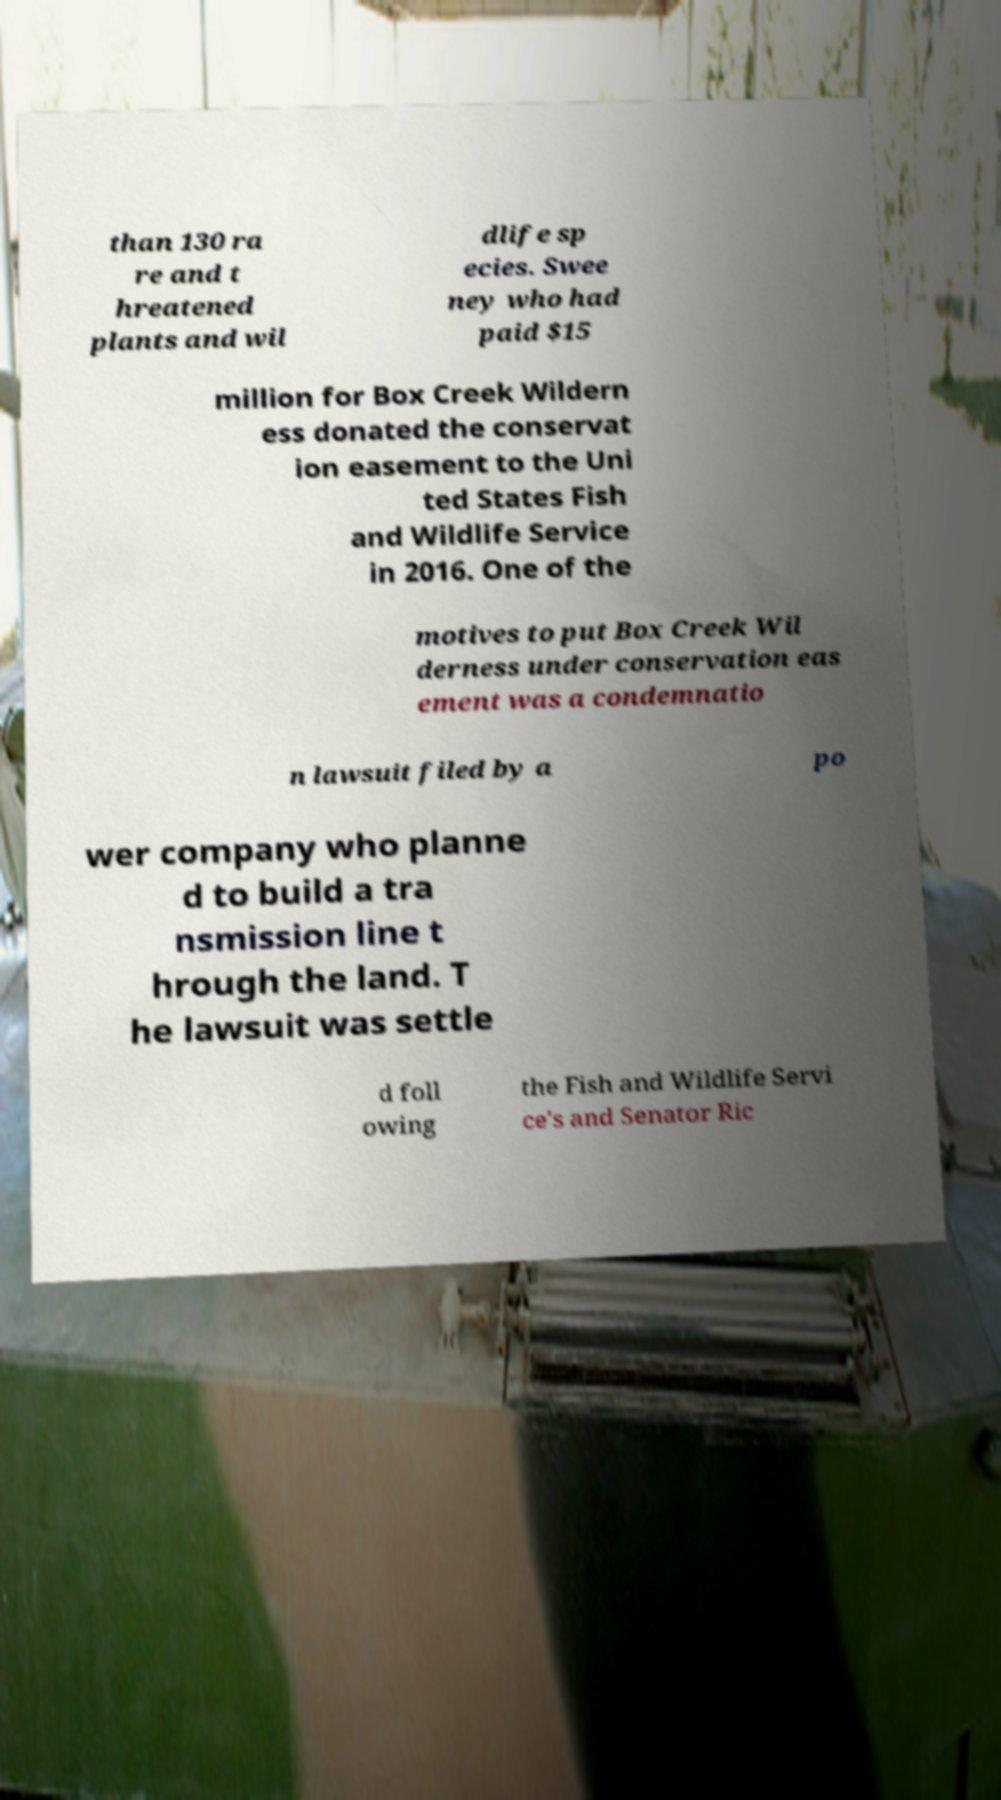Could you assist in decoding the text presented in this image and type it out clearly? than 130 ra re and t hreatened plants and wil dlife sp ecies. Swee ney who had paid $15 million for Box Creek Wildern ess donated the conservat ion easement to the Uni ted States Fish and Wildlife Service in 2016. One of the motives to put Box Creek Wil derness under conservation eas ement was a condemnatio n lawsuit filed by a po wer company who planne d to build a tra nsmission line t hrough the land. T he lawsuit was settle d foll owing the Fish and Wildlife Servi ce's and Senator Ric 